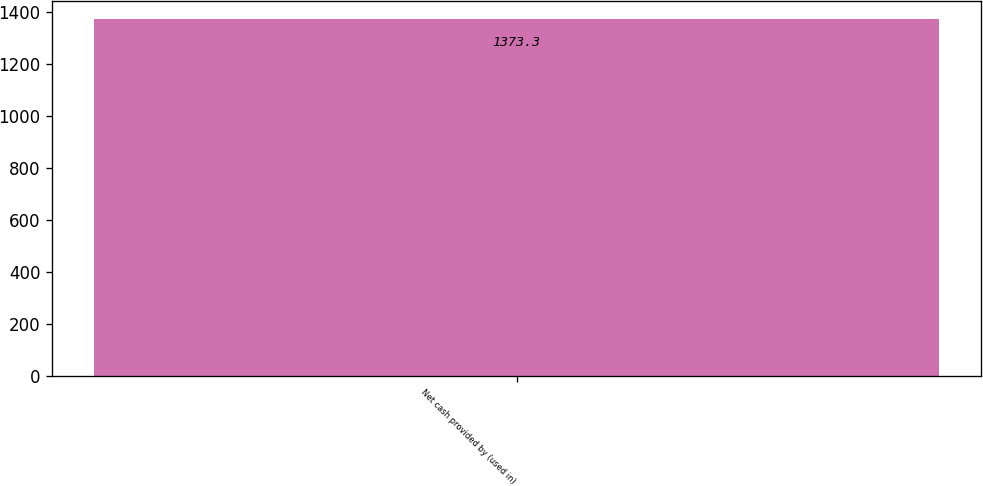Convert chart to OTSL. <chart><loc_0><loc_0><loc_500><loc_500><bar_chart><fcel>Net cash provided by (used in)<nl><fcel>1373.3<nl></chart> 